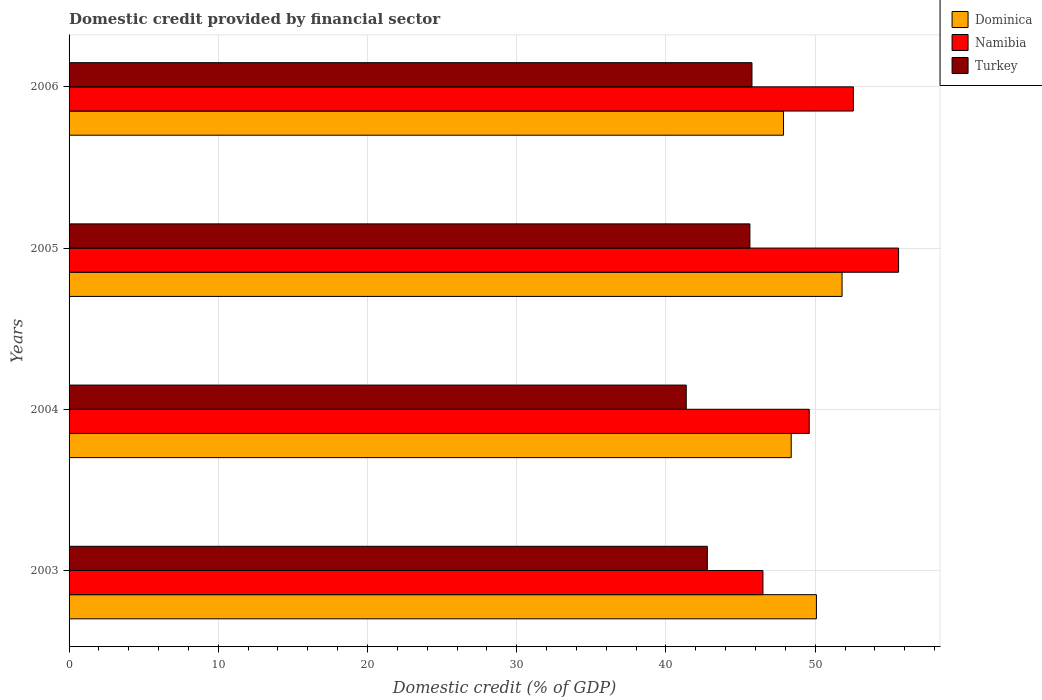Are the number of bars per tick equal to the number of legend labels?
Offer a terse response. Yes. Are the number of bars on each tick of the Y-axis equal?
Provide a short and direct response. Yes. How many bars are there on the 1st tick from the bottom?
Give a very brief answer. 3. What is the label of the 1st group of bars from the top?
Provide a short and direct response. 2006. What is the domestic credit in Dominica in 2006?
Your answer should be compact. 47.88. Across all years, what is the maximum domestic credit in Dominica?
Your response must be concise. 51.8. Across all years, what is the minimum domestic credit in Turkey?
Give a very brief answer. 41.36. In which year was the domestic credit in Dominica maximum?
Offer a terse response. 2005. In which year was the domestic credit in Namibia minimum?
Provide a short and direct response. 2003. What is the total domestic credit in Turkey in the graph?
Your answer should be compact. 175.53. What is the difference between the domestic credit in Namibia in 2003 and that in 2005?
Offer a very short reply. -9.09. What is the difference between the domestic credit in Dominica in 2004 and the domestic credit in Turkey in 2003?
Your response must be concise. 5.62. What is the average domestic credit in Namibia per year?
Your answer should be very brief. 51.06. In the year 2006, what is the difference between the domestic credit in Turkey and domestic credit in Namibia?
Ensure brevity in your answer.  -6.8. In how many years, is the domestic credit in Namibia greater than 36 %?
Offer a very short reply. 4. What is the ratio of the domestic credit in Turkey in 2004 to that in 2005?
Offer a terse response. 0.91. What is the difference between the highest and the second highest domestic credit in Dominica?
Your answer should be very brief. 1.72. What is the difference between the highest and the lowest domestic credit in Namibia?
Give a very brief answer. 9.09. In how many years, is the domestic credit in Turkey greater than the average domestic credit in Turkey taken over all years?
Provide a short and direct response. 2. What does the 2nd bar from the top in 2005 represents?
Provide a short and direct response. Namibia. Is it the case that in every year, the sum of the domestic credit in Turkey and domestic credit in Dominica is greater than the domestic credit in Namibia?
Your answer should be compact. Yes. How many bars are there?
Keep it short and to the point. 12. Are all the bars in the graph horizontal?
Your answer should be very brief. Yes. Are the values on the major ticks of X-axis written in scientific E-notation?
Ensure brevity in your answer.  No. Where does the legend appear in the graph?
Ensure brevity in your answer.  Top right. How are the legend labels stacked?
Offer a terse response. Vertical. What is the title of the graph?
Ensure brevity in your answer.  Domestic credit provided by financial sector. What is the label or title of the X-axis?
Make the answer very short. Domestic credit (% of GDP). What is the Domestic credit (% of GDP) of Dominica in 2003?
Offer a very short reply. 50.09. What is the Domestic credit (% of GDP) in Namibia in 2003?
Keep it short and to the point. 46.5. What is the Domestic credit (% of GDP) of Turkey in 2003?
Keep it short and to the point. 42.77. What is the Domestic credit (% of GDP) in Dominica in 2004?
Offer a terse response. 48.4. What is the Domestic credit (% of GDP) in Namibia in 2004?
Make the answer very short. 49.6. What is the Domestic credit (% of GDP) in Turkey in 2004?
Provide a short and direct response. 41.36. What is the Domestic credit (% of GDP) of Dominica in 2005?
Offer a very short reply. 51.8. What is the Domestic credit (% of GDP) in Namibia in 2005?
Your answer should be compact. 55.59. What is the Domestic credit (% of GDP) in Turkey in 2005?
Ensure brevity in your answer.  45.63. What is the Domestic credit (% of GDP) of Dominica in 2006?
Offer a very short reply. 47.88. What is the Domestic credit (% of GDP) in Namibia in 2006?
Provide a succinct answer. 52.56. What is the Domestic credit (% of GDP) in Turkey in 2006?
Ensure brevity in your answer.  45.77. Across all years, what is the maximum Domestic credit (% of GDP) in Dominica?
Offer a terse response. 51.8. Across all years, what is the maximum Domestic credit (% of GDP) of Namibia?
Offer a very short reply. 55.59. Across all years, what is the maximum Domestic credit (% of GDP) of Turkey?
Offer a terse response. 45.77. Across all years, what is the minimum Domestic credit (% of GDP) of Dominica?
Give a very brief answer. 47.88. Across all years, what is the minimum Domestic credit (% of GDP) in Namibia?
Offer a very short reply. 46.5. Across all years, what is the minimum Domestic credit (% of GDP) of Turkey?
Give a very brief answer. 41.36. What is the total Domestic credit (% of GDP) in Dominica in the graph?
Give a very brief answer. 198.16. What is the total Domestic credit (% of GDP) of Namibia in the graph?
Provide a short and direct response. 204.26. What is the total Domestic credit (% of GDP) of Turkey in the graph?
Make the answer very short. 175.53. What is the difference between the Domestic credit (% of GDP) of Dominica in 2003 and that in 2004?
Ensure brevity in your answer.  1.69. What is the difference between the Domestic credit (% of GDP) of Namibia in 2003 and that in 2004?
Give a very brief answer. -3.1. What is the difference between the Domestic credit (% of GDP) of Turkey in 2003 and that in 2004?
Your answer should be very brief. 1.41. What is the difference between the Domestic credit (% of GDP) of Dominica in 2003 and that in 2005?
Give a very brief answer. -1.72. What is the difference between the Domestic credit (% of GDP) in Namibia in 2003 and that in 2005?
Keep it short and to the point. -9.09. What is the difference between the Domestic credit (% of GDP) in Turkey in 2003 and that in 2005?
Provide a short and direct response. -2.85. What is the difference between the Domestic credit (% of GDP) in Dominica in 2003 and that in 2006?
Provide a short and direct response. 2.21. What is the difference between the Domestic credit (% of GDP) of Namibia in 2003 and that in 2006?
Your response must be concise. -6.06. What is the difference between the Domestic credit (% of GDP) in Turkey in 2003 and that in 2006?
Ensure brevity in your answer.  -2.99. What is the difference between the Domestic credit (% of GDP) of Dominica in 2004 and that in 2005?
Offer a very short reply. -3.41. What is the difference between the Domestic credit (% of GDP) in Namibia in 2004 and that in 2005?
Make the answer very short. -5.99. What is the difference between the Domestic credit (% of GDP) of Turkey in 2004 and that in 2005?
Keep it short and to the point. -4.27. What is the difference between the Domestic credit (% of GDP) in Dominica in 2004 and that in 2006?
Your answer should be very brief. 0.52. What is the difference between the Domestic credit (% of GDP) in Namibia in 2004 and that in 2006?
Make the answer very short. -2.96. What is the difference between the Domestic credit (% of GDP) in Turkey in 2004 and that in 2006?
Make the answer very short. -4.41. What is the difference between the Domestic credit (% of GDP) of Dominica in 2005 and that in 2006?
Your answer should be compact. 3.92. What is the difference between the Domestic credit (% of GDP) of Namibia in 2005 and that in 2006?
Provide a short and direct response. 3.03. What is the difference between the Domestic credit (% of GDP) in Turkey in 2005 and that in 2006?
Offer a very short reply. -0.14. What is the difference between the Domestic credit (% of GDP) in Dominica in 2003 and the Domestic credit (% of GDP) in Namibia in 2004?
Your answer should be very brief. 0.48. What is the difference between the Domestic credit (% of GDP) in Dominica in 2003 and the Domestic credit (% of GDP) in Turkey in 2004?
Keep it short and to the point. 8.73. What is the difference between the Domestic credit (% of GDP) of Namibia in 2003 and the Domestic credit (% of GDP) of Turkey in 2004?
Your answer should be compact. 5.14. What is the difference between the Domestic credit (% of GDP) of Dominica in 2003 and the Domestic credit (% of GDP) of Namibia in 2005?
Keep it short and to the point. -5.51. What is the difference between the Domestic credit (% of GDP) in Dominica in 2003 and the Domestic credit (% of GDP) in Turkey in 2005?
Offer a very short reply. 4.46. What is the difference between the Domestic credit (% of GDP) of Namibia in 2003 and the Domestic credit (% of GDP) of Turkey in 2005?
Keep it short and to the point. 0.87. What is the difference between the Domestic credit (% of GDP) in Dominica in 2003 and the Domestic credit (% of GDP) in Namibia in 2006?
Offer a terse response. -2.48. What is the difference between the Domestic credit (% of GDP) of Dominica in 2003 and the Domestic credit (% of GDP) of Turkey in 2006?
Your answer should be compact. 4.32. What is the difference between the Domestic credit (% of GDP) in Namibia in 2003 and the Domestic credit (% of GDP) in Turkey in 2006?
Your response must be concise. 0.74. What is the difference between the Domestic credit (% of GDP) in Dominica in 2004 and the Domestic credit (% of GDP) in Namibia in 2005?
Your response must be concise. -7.2. What is the difference between the Domestic credit (% of GDP) of Dominica in 2004 and the Domestic credit (% of GDP) of Turkey in 2005?
Your response must be concise. 2.77. What is the difference between the Domestic credit (% of GDP) of Namibia in 2004 and the Domestic credit (% of GDP) of Turkey in 2005?
Make the answer very short. 3.98. What is the difference between the Domestic credit (% of GDP) in Dominica in 2004 and the Domestic credit (% of GDP) in Namibia in 2006?
Offer a terse response. -4.17. What is the difference between the Domestic credit (% of GDP) of Dominica in 2004 and the Domestic credit (% of GDP) of Turkey in 2006?
Make the answer very short. 2.63. What is the difference between the Domestic credit (% of GDP) in Namibia in 2004 and the Domestic credit (% of GDP) in Turkey in 2006?
Offer a terse response. 3.84. What is the difference between the Domestic credit (% of GDP) in Dominica in 2005 and the Domestic credit (% of GDP) in Namibia in 2006?
Your answer should be very brief. -0.76. What is the difference between the Domestic credit (% of GDP) of Dominica in 2005 and the Domestic credit (% of GDP) of Turkey in 2006?
Your response must be concise. 6.04. What is the difference between the Domestic credit (% of GDP) of Namibia in 2005 and the Domestic credit (% of GDP) of Turkey in 2006?
Offer a very short reply. 9.83. What is the average Domestic credit (% of GDP) in Dominica per year?
Offer a terse response. 49.54. What is the average Domestic credit (% of GDP) in Namibia per year?
Provide a succinct answer. 51.06. What is the average Domestic credit (% of GDP) in Turkey per year?
Your answer should be compact. 43.88. In the year 2003, what is the difference between the Domestic credit (% of GDP) of Dominica and Domestic credit (% of GDP) of Namibia?
Give a very brief answer. 3.58. In the year 2003, what is the difference between the Domestic credit (% of GDP) of Dominica and Domestic credit (% of GDP) of Turkey?
Give a very brief answer. 7.31. In the year 2003, what is the difference between the Domestic credit (% of GDP) of Namibia and Domestic credit (% of GDP) of Turkey?
Provide a succinct answer. 3.73. In the year 2004, what is the difference between the Domestic credit (% of GDP) of Dominica and Domestic credit (% of GDP) of Namibia?
Ensure brevity in your answer.  -1.21. In the year 2004, what is the difference between the Domestic credit (% of GDP) in Dominica and Domestic credit (% of GDP) in Turkey?
Make the answer very short. 7.04. In the year 2004, what is the difference between the Domestic credit (% of GDP) in Namibia and Domestic credit (% of GDP) in Turkey?
Give a very brief answer. 8.24. In the year 2005, what is the difference between the Domestic credit (% of GDP) in Dominica and Domestic credit (% of GDP) in Namibia?
Make the answer very short. -3.79. In the year 2005, what is the difference between the Domestic credit (% of GDP) in Dominica and Domestic credit (% of GDP) in Turkey?
Make the answer very short. 6.18. In the year 2005, what is the difference between the Domestic credit (% of GDP) of Namibia and Domestic credit (% of GDP) of Turkey?
Your answer should be very brief. 9.96. In the year 2006, what is the difference between the Domestic credit (% of GDP) of Dominica and Domestic credit (% of GDP) of Namibia?
Ensure brevity in your answer.  -4.68. In the year 2006, what is the difference between the Domestic credit (% of GDP) of Dominica and Domestic credit (% of GDP) of Turkey?
Provide a short and direct response. 2.11. In the year 2006, what is the difference between the Domestic credit (% of GDP) of Namibia and Domestic credit (% of GDP) of Turkey?
Ensure brevity in your answer.  6.8. What is the ratio of the Domestic credit (% of GDP) in Dominica in 2003 to that in 2004?
Give a very brief answer. 1.03. What is the ratio of the Domestic credit (% of GDP) of Namibia in 2003 to that in 2004?
Provide a succinct answer. 0.94. What is the ratio of the Domestic credit (% of GDP) in Turkey in 2003 to that in 2004?
Offer a very short reply. 1.03. What is the ratio of the Domestic credit (% of GDP) of Dominica in 2003 to that in 2005?
Provide a short and direct response. 0.97. What is the ratio of the Domestic credit (% of GDP) of Namibia in 2003 to that in 2005?
Your answer should be very brief. 0.84. What is the ratio of the Domestic credit (% of GDP) of Dominica in 2003 to that in 2006?
Provide a short and direct response. 1.05. What is the ratio of the Domestic credit (% of GDP) of Namibia in 2003 to that in 2006?
Make the answer very short. 0.88. What is the ratio of the Domestic credit (% of GDP) in Turkey in 2003 to that in 2006?
Ensure brevity in your answer.  0.93. What is the ratio of the Domestic credit (% of GDP) in Dominica in 2004 to that in 2005?
Keep it short and to the point. 0.93. What is the ratio of the Domestic credit (% of GDP) of Namibia in 2004 to that in 2005?
Give a very brief answer. 0.89. What is the ratio of the Domestic credit (% of GDP) of Turkey in 2004 to that in 2005?
Your response must be concise. 0.91. What is the ratio of the Domestic credit (% of GDP) of Dominica in 2004 to that in 2006?
Provide a short and direct response. 1.01. What is the ratio of the Domestic credit (% of GDP) in Namibia in 2004 to that in 2006?
Your answer should be compact. 0.94. What is the ratio of the Domestic credit (% of GDP) of Turkey in 2004 to that in 2006?
Make the answer very short. 0.9. What is the ratio of the Domestic credit (% of GDP) in Dominica in 2005 to that in 2006?
Make the answer very short. 1.08. What is the ratio of the Domestic credit (% of GDP) in Namibia in 2005 to that in 2006?
Your answer should be very brief. 1.06. What is the difference between the highest and the second highest Domestic credit (% of GDP) in Dominica?
Provide a succinct answer. 1.72. What is the difference between the highest and the second highest Domestic credit (% of GDP) of Namibia?
Make the answer very short. 3.03. What is the difference between the highest and the second highest Domestic credit (% of GDP) in Turkey?
Your response must be concise. 0.14. What is the difference between the highest and the lowest Domestic credit (% of GDP) of Dominica?
Keep it short and to the point. 3.92. What is the difference between the highest and the lowest Domestic credit (% of GDP) of Namibia?
Offer a very short reply. 9.09. What is the difference between the highest and the lowest Domestic credit (% of GDP) in Turkey?
Ensure brevity in your answer.  4.41. 